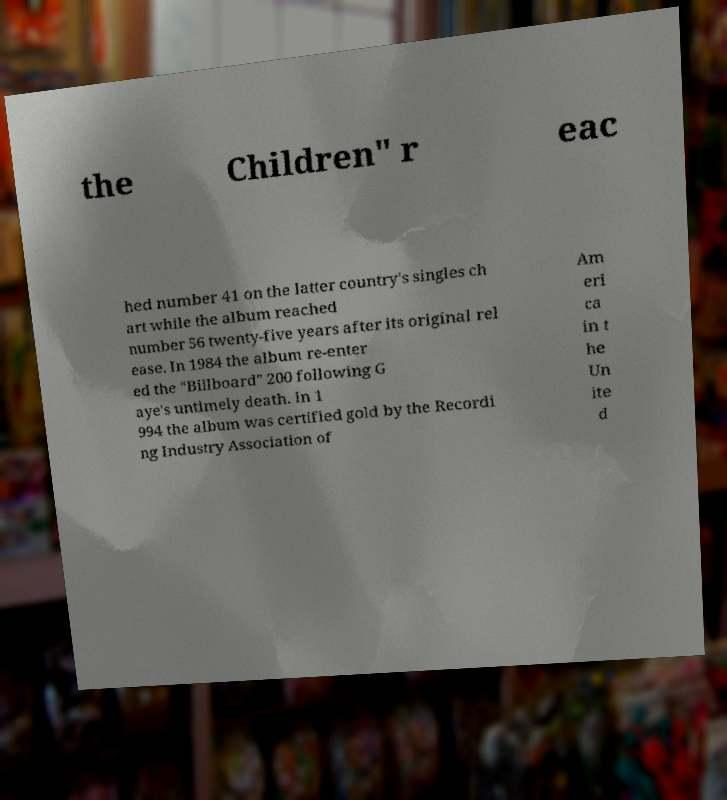Can you accurately transcribe the text from the provided image for me? the Children" r eac hed number 41 on the latter country's singles ch art while the album reached number 56 twenty-five years after its original rel ease. In 1984 the album re-enter ed the "Billboard" 200 following G aye's untimely death. In 1 994 the album was certified gold by the Recordi ng Industry Association of Am eri ca in t he Un ite d 